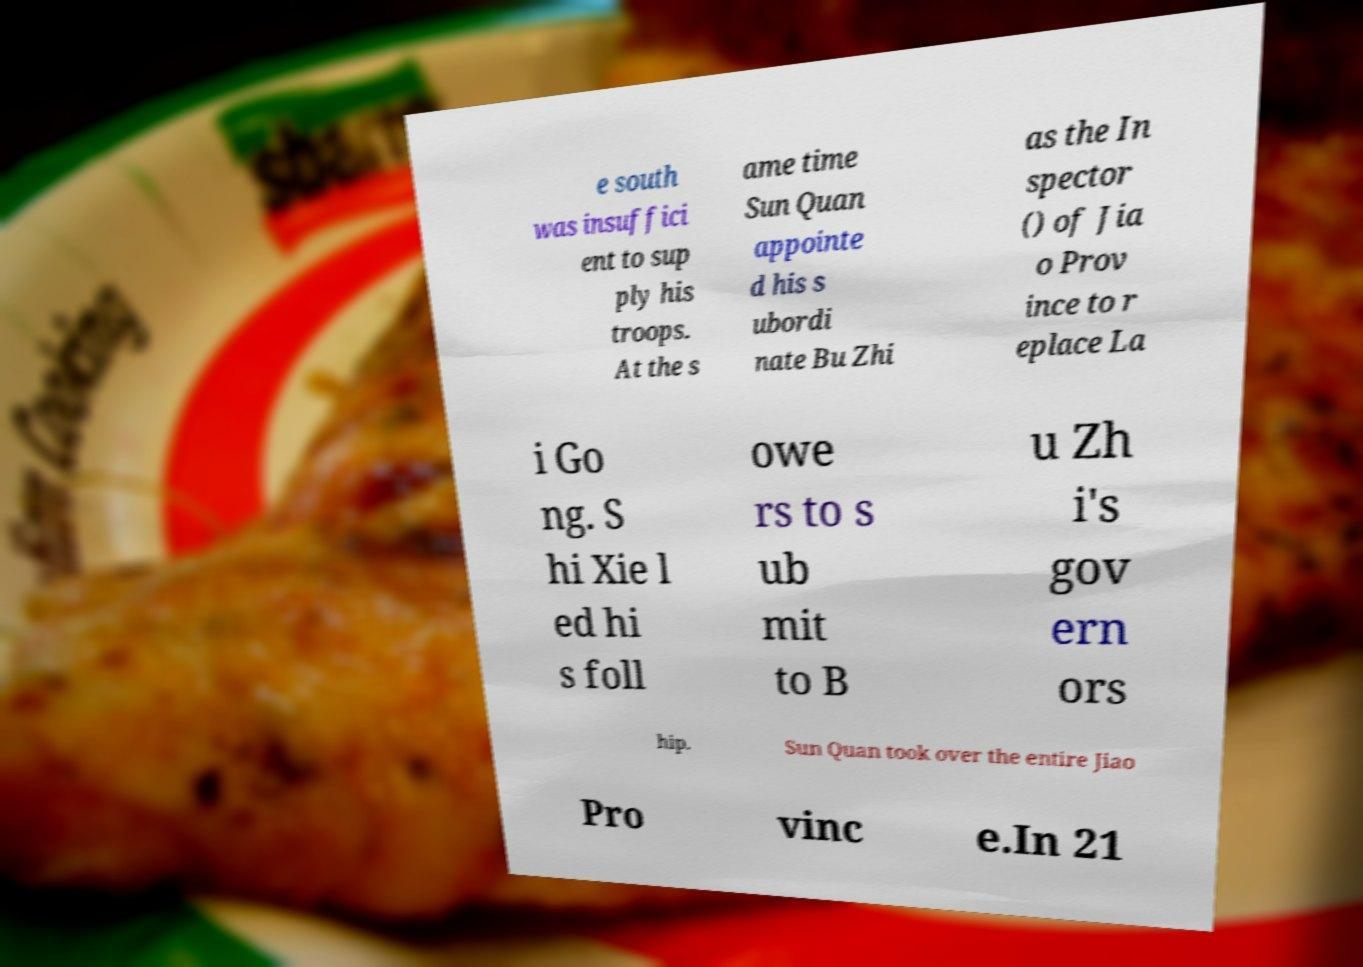Could you extract and type out the text from this image? e south was insuffici ent to sup ply his troops. At the s ame time Sun Quan appointe d his s ubordi nate Bu Zhi as the In spector () of Jia o Prov ince to r eplace La i Go ng. S hi Xie l ed hi s foll owe rs to s ub mit to B u Zh i's gov ern ors hip. Sun Quan took over the entire Jiao Pro vinc e.In 21 